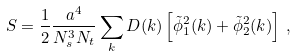Convert formula to latex. <formula><loc_0><loc_0><loc_500><loc_500>S = \frac { 1 } { 2 } \frac { a ^ { 4 } } { N _ { s } ^ { 3 } N _ { t } } \sum _ { k } D ( k ) \left [ \tilde { \phi } _ { 1 } ^ { 2 } ( k ) + \tilde { \phi } _ { 2 } ^ { 2 } ( k ) \right ] \, ,</formula> 